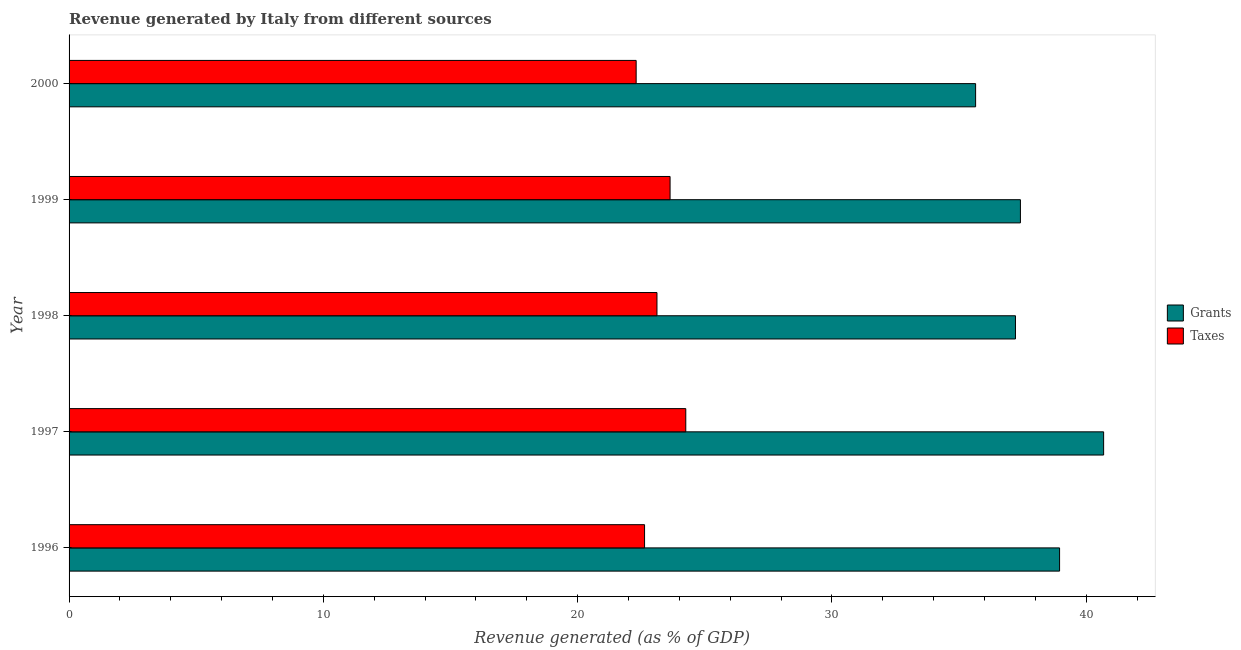How many different coloured bars are there?
Give a very brief answer. 2. How many groups of bars are there?
Offer a terse response. 5. How many bars are there on the 1st tick from the top?
Your answer should be compact. 2. What is the revenue generated by grants in 1998?
Offer a very short reply. 37.22. Across all years, what is the maximum revenue generated by grants?
Make the answer very short. 40.68. Across all years, what is the minimum revenue generated by grants?
Provide a succinct answer. 35.65. In which year was the revenue generated by taxes maximum?
Your answer should be very brief. 1997. In which year was the revenue generated by grants minimum?
Provide a succinct answer. 2000. What is the total revenue generated by taxes in the graph?
Give a very brief answer. 115.94. What is the difference between the revenue generated by taxes in 1997 and that in 2000?
Your response must be concise. 1.95. What is the difference between the revenue generated by grants in 1998 and the revenue generated by taxes in 1997?
Your answer should be very brief. 12.96. What is the average revenue generated by grants per year?
Provide a succinct answer. 37.98. In the year 1996, what is the difference between the revenue generated by taxes and revenue generated by grants?
Provide a short and direct response. -16.32. In how many years, is the revenue generated by taxes greater than 28 %?
Provide a short and direct response. 0. What is the ratio of the revenue generated by grants in 1998 to that in 2000?
Give a very brief answer. 1.04. Is the revenue generated by grants in 1997 less than that in 1998?
Offer a terse response. No. Is the difference between the revenue generated by taxes in 1996 and 1997 greater than the difference between the revenue generated by grants in 1996 and 1997?
Your answer should be very brief. Yes. What is the difference between the highest and the second highest revenue generated by grants?
Offer a terse response. 1.73. What is the difference between the highest and the lowest revenue generated by grants?
Offer a very short reply. 5.03. In how many years, is the revenue generated by taxes greater than the average revenue generated by taxes taken over all years?
Give a very brief answer. 2. Is the sum of the revenue generated by grants in 1999 and 2000 greater than the maximum revenue generated by taxes across all years?
Provide a short and direct response. Yes. What does the 2nd bar from the top in 1996 represents?
Provide a succinct answer. Grants. What does the 2nd bar from the bottom in 1998 represents?
Offer a terse response. Taxes. Are all the bars in the graph horizontal?
Give a very brief answer. Yes. Where does the legend appear in the graph?
Make the answer very short. Center right. How many legend labels are there?
Make the answer very short. 2. How are the legend labels stacked?
Keep it short and to the point. Vertical. What is the title of the graph?
Ensure brevity in your answer.  Revenue generated by Italy from different sources. What is the label or title of the X-axis?
Make the answer very short. Revenue generated (as % of GDP). What is the Revenue generated (as % of GDP) in Grants in 1996?
Offer a very short reply. 38.95. What is the Revenue generated (as % of GDP) in Taxes in 1996?
Offer a very short reply. 22.63. What is the Revenue generated (as % of GDP) in Grants in 1997?
Ensure brevity in your answer.  40.68. What is the Revenue generated (as % of GDP) in Taxes in 1997?
Your answer should be compact. 24.25. What is the Revenue generated (as % of GDP) of Grants in 1998?
Keep it short and to the point. 37.22. What is the Revenue generated (as % of GDP) in Taxes in 1998?
Your answer should be very brief. 23.12. What is the Revenue generated (as % of GDP) in Grants in 1999?
Offer a terse response. 37.41. What is the Revenue generated (as % of GDP) of Taxes in 1999?
Ensure brevity in your answer.  23.63. What is the Revenue generated (as % of GDP) of Grants in 2000?
Offer a very short reply. 35.65. What is the Revenue generated (as % of GDP) of Taxes in 2000?
Offer a very short reply. 22.3. Across all years, what is the maximum Revenue generated (as % of GDP) in Grants?
Provide a short and direct response. 40.68. Across all years, what is the maximum Revenue generated (as % of GDP) of Taxes?
Offer a terse response. 24.25. Across all years, what is the minimum Revenue generated (as % of GDP) of Grants?
Your answer should be compact. 35.65. Across all years, what is the minimum Revenue generated (as % of GDP) of Taxes?
Make the answer very short. 22.3. What is the total Revenue generated (as % of GDP) of Grants in the graph?
Provide a succinct answer. 189.92. What is the total Revenue generated (as % of GDP) in Taxes in the graph?
Offer a very short reply. 115.94. What is the difference between the Revenue generated (as % of GDP) in Grants in 1996 and that in 1997?
Your answer should be compact. -1.73. What is the difference between the Revenue generated (as % of GDP) of Taxes in 1996 and that in 1997?
Make the answer very short. -1.62. What is the difference between the Revenue generated (as % of GDP) in Grants in 1996 and that in 1998?
Your answer should be compact. 1.73. What is the difference between the Revenue generated (as % of GDP) of Taxes in 1996 and that in 1998?
Give a very brief answer. -0.49. What is the difference between the Revenue generated (as % of GDP) in Grants in 1996 and that in 1999?
Give a very brief answer. 1.54. What is the difference between the Revenue generated (as % of GDP) in Taxes in 1996 and that in 1999?
Your answer should be very brief. -1. What is the difference between the Revenue generated (as % of GDP) of Grants in 1996 and that in 2000?
Provide a short and direct response. 3.3. What is the difference between the Revenue generated (as % of GDP) in Taxes in 1996 and that in 2000?
Make the answer very short. 0.33. What is the difference between the Revenue generated (as % of GDP) of Grants in 1997 and that in 1998?
Your answer should be very brief. 3.47. What is the difference between the Revenue generated (as % of GDP) in Taxes in 1997 and that in 1998?
Make the answer very short. 1.13. What is the difference between the Revenue generated (as % of GDP) of Grants in 1997 and that in 1999?
Give a very brief answer. 3.27. What is the difference between the Revenue generated (as % of GDP) in Taxes in 1997 and that in 1999?
Ensure brevity in your answer.  0.62. What is the difference between the Revenue generated (as % of GDP) in Grants in 1997 and that in 2000?
Your answer should be compact. 5.03. What is the difference between the Revenue generated (as % of GDP) of Taxes in 1997 and that in 2000?
Offer a very short reply. 1.95. What is the difference between the Revenue generated (as % of GDP) in Grants in 1998 and that in 1999?
Give a very brief answer. -0.19. What is the difference between the Revenue generated (as % of GDP) in Taxes in 1998 and that in 1999?
Ensure brevity in your answer.  -0.52. What is the difference between the Revenue generated (as % of GDP) of Grants in 1998 and that in 2000?
Your answer should be very brief. 1.57. What is the difference between the Revenue generated (as % of GDP) in Taxes in 1998 and that in 2000?
Provide a short and direct response. 0.82. What is the difference between the Revenue generated (as % of GDP) of Grants in 1999 and that in 2000?
Provide a succinct answer. 1.76. What is the difference between the Revenue generated (as % of GDP) in Taxes in 1999 and that in 2000?
Your answer should be very brief. 1.33. What is the difference between the Revenue generated (as % of GDP) of Grants in 1996 and the Revenue generated (as % of GDP) of Taxes in 1997?
Your answer should be compact. 14.7. What is the difference between the Revenue generated (as % of GDP) of Grants in 1996 and the Revenue generated (as % of GDP) of Taxes in 1998?
Ensure brevity in your answer.  15.83. What is the difference between the Revenue generated (as % of GDP) in Grants in 1996 and the Revenue generated (as % of GDP) in Taxes in 1999?
Your answer should be very brief. 15.32. What is the difference between the Revenue generated (as % of GDP) in Grants in 1996 and the Revenue generated (as % of GDP) in Taxes in 2000?
Your answer should be very brief. 16.65. What is the difference between the Revenue generated (as % of GDP) in Grants in 1997 and the Revenue generated (as % of GDP) in Taxes in 1998?
Your answer should be very brief. 17.57. What is the difference between the Revenue generated (as % of GDP) in Grants in 1997 and the Revenue generated (as % of GDP) in Taxes in 1999?
Make the answer very short. 17.05. What is the difference between the Revenue generated (as % of GDP) in Grants in 1997 and the Revenue generated (as % of GDP) in Taxes in 2000?
Offer a very short reply. 18.38. What is the difference between the Revenue generated (as % of GDP) of Grants in 1998 and the Revenue generated (as % of GDP) of Taxes in 1999?
Offer a terse response. 13.58. What is the difference between the Revenue generated (as % of GDP) in Grants in 1998 and the Revenue generated (as % of GDP) in Taxes in 2000?
Your response must be concise. 14.92. What is the difference between the Revenue generated (as % of GDP) of Grants in 1999 and the Revenue generated (as % of GDP) of Taxes in 2000?
Make the answer very short. 15.11. What is the average Revenue generated (as % of GDP) in Grants per year?
Provide a succinct answer. 37.98. What is the average Revenue generated (as % of GDP) in Taxes per year?
Provide a short and direct response. 23.19. In the year 1996, what is the difference between the Revenue generated (as % of GDP) in Grants and Revenue generated (as % of GDP) in Taxes?
Ensure brevity in your answer.  16.32. In the year 1997, what is the difference between the Revenue generated (as % of GDP) in Grants and Revenue generated (as % of GDP) in Taxes?
Offer a very short reply. 16.43. In the year 1998, what is the difference between the Revenue generated (as % of GDP) of Grants and Revenue generated (as % of GDP) of Taxes?
Your response must be concise. 14.1. In the year 1999, what is the difference between the Revenue generated (as % of GDP) of Grants and Revenue generated (as % of GDP) of Taxes?
Give a very brief answer. 13.78. In the year 2000, what is the difference between the Revenue generated (as % of GDP) in Grants and Revenue generated (as % of GDP) in Taxes?
Your response must be concise. 13.35. What is the ratio of the Revenue generated (as % of GDP) of Grants in 1996 to that in 1997?
Provide a short and direct response. 0.96. What is the ratio of the Revenue generated (as % of GDP) of Taxes in 1996 to that in 1997?
Keep it short and to the point. 0.93. What is the ratio of the Revenue generated (as % of GDP) in Grants in 1996 to that in 1998?
Make the answer very short. 1.05. What is the ratio of the Revenue generated (as % of GDP) in Taxes in 1996 to that in 1998?
Ensure brevity in your answer.  0.98. What is the ratio of the Revenue generated (as % of GDP) of Grants in 1996 to that in 1999?
Your answer should be very brief. 1.04. What is the ratio of the Revenue generated (as % of GDP) in Taxes in 1996 to that in 1999?
Make the answer very short. 0.96. What is the ratio of the Revenue generated (as % of GDP) of Grants in 1996 to that in 2000?
Your answer should be very brief. 1.09. What is the ratio of the Revenue generated (as % of GDP) of Taxes in 1996 to that in 2000?
Your response must be concise. 1.01. What is the ratio of the Revenue generated (as % of GDP) of Grants in 1997 to that in 1998?
Provide a short and direct response. 1.09. What is the ratio of the Revenue generated (as % of GDP) of Taxes in 1997 to that in 1998?
Give a very brief answer. 1.05. What is the ratio of the Revenue generated (as % of GDP) of Grants in 1997 to that in 1999?
Your answer should be very brief. 1.09. What is the ratio of the Revenue generated (as % of GDP) in Taxes in 1997 to that in 1999?
Keep it short and to the point. 1.03. What is the ratio of the Revenue generated (as % of GDP) in Grants in 1997 to that in 2000?
Give a very brief answer. 1.14. What is the ratio of the Revenue generated (as % of GDP) of Taxes in 1997 to that in 2000?
Provide a succinct answer. 1.09. What is the ratio of the Revenue generated (as % of GDP) of Taxes in 1998 to that in 1999?
Make the answer very short. 0.98. What is the ratio of the Revenue generated (as % of GDP) of Grants in 1998 to that in 2000?
Provide a succinct answer. 1.04. What is the ratio of the Revenue generated (as % of GDP) in Taxes in 1998 to that in 2000?
Ensure brevity in your answer.  1.04. What is the ratio of the Revenue generated (as % of GDP) of Grants in 1999 to that in 2000?
Ensure brevity in your answer.  1.05. What is the ratio of the Revenue generated (as % of GDP) in Taxes in 1999 to that in 2000?
Provide a short and direct response. 1.06. What is the difference between the highest and the second highest Revenue generated (as % of GDP) of Grants?
Offer a terse response. 1.73. What is the difference between the highest and the second highest Revenue generated (as % of GDP) in Taxes?
Keep it short and to the point. 0.62. What is the difference between the highest and the lowest Revenue generated (as % of GDP) of Grants?
Provide a succinct answer. 5.03. What is the difference between the highest and the lowest Revenue generated (as % of GDP) of Taxes?
Ensure brevity in your answer.  1.95. 